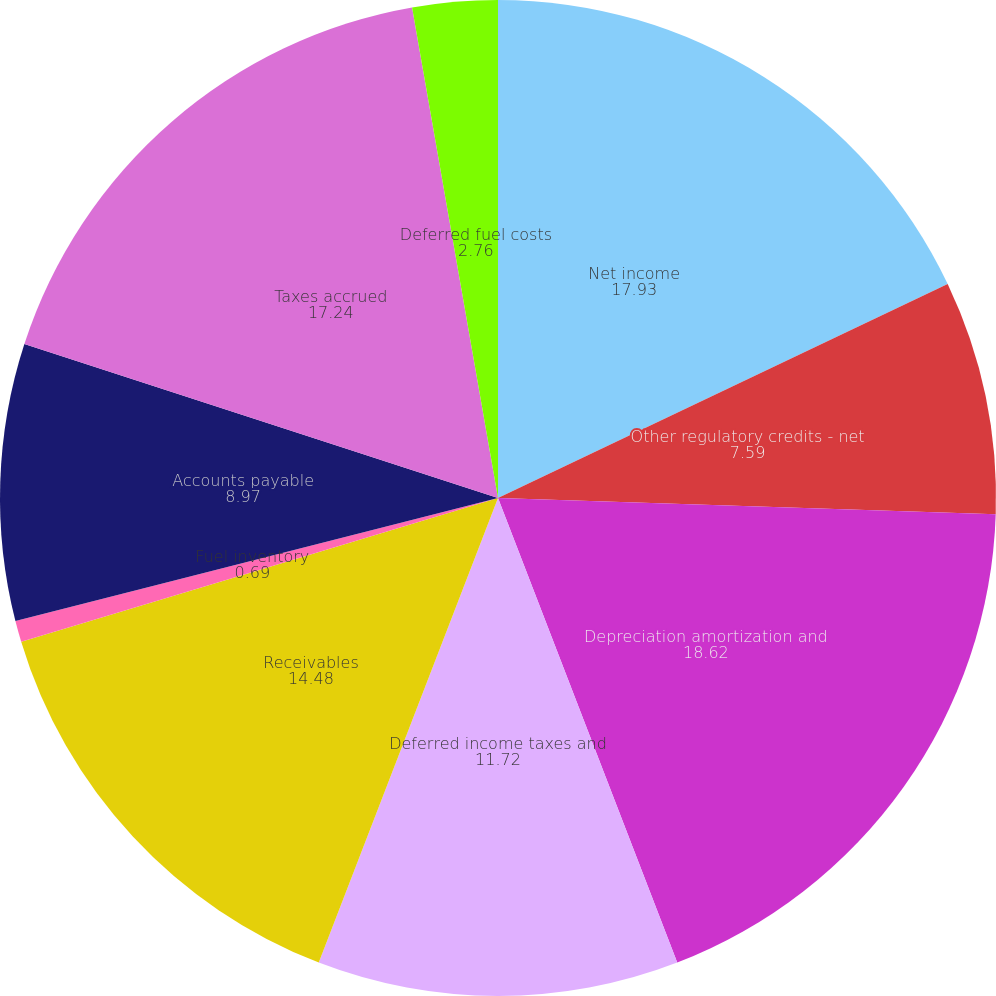Convert chart. <chart><loc_0><loc_0><loc_500><loc_500><pie_chart><fcel>Net income<fcel>Other regulatory credits - net<fcel>Depreciation amortization and<fcel>Deferred income taxes and<fcel>Receivables<fcel>Fuel inventory<fcel>Accounts payable<fcel>Taxes accrued<fcel>Interest accrued<fcel>Deferred fuel costs<nl><fcel>17.93%<fcel>7.59%<fcel>18.62%<fcel>11.72%<fcel>14.48%<fcel>0.69%<fcel>8.97%<fcel>17.24%<fcel>0.0%<fcel>2.76%<nl></chart> 